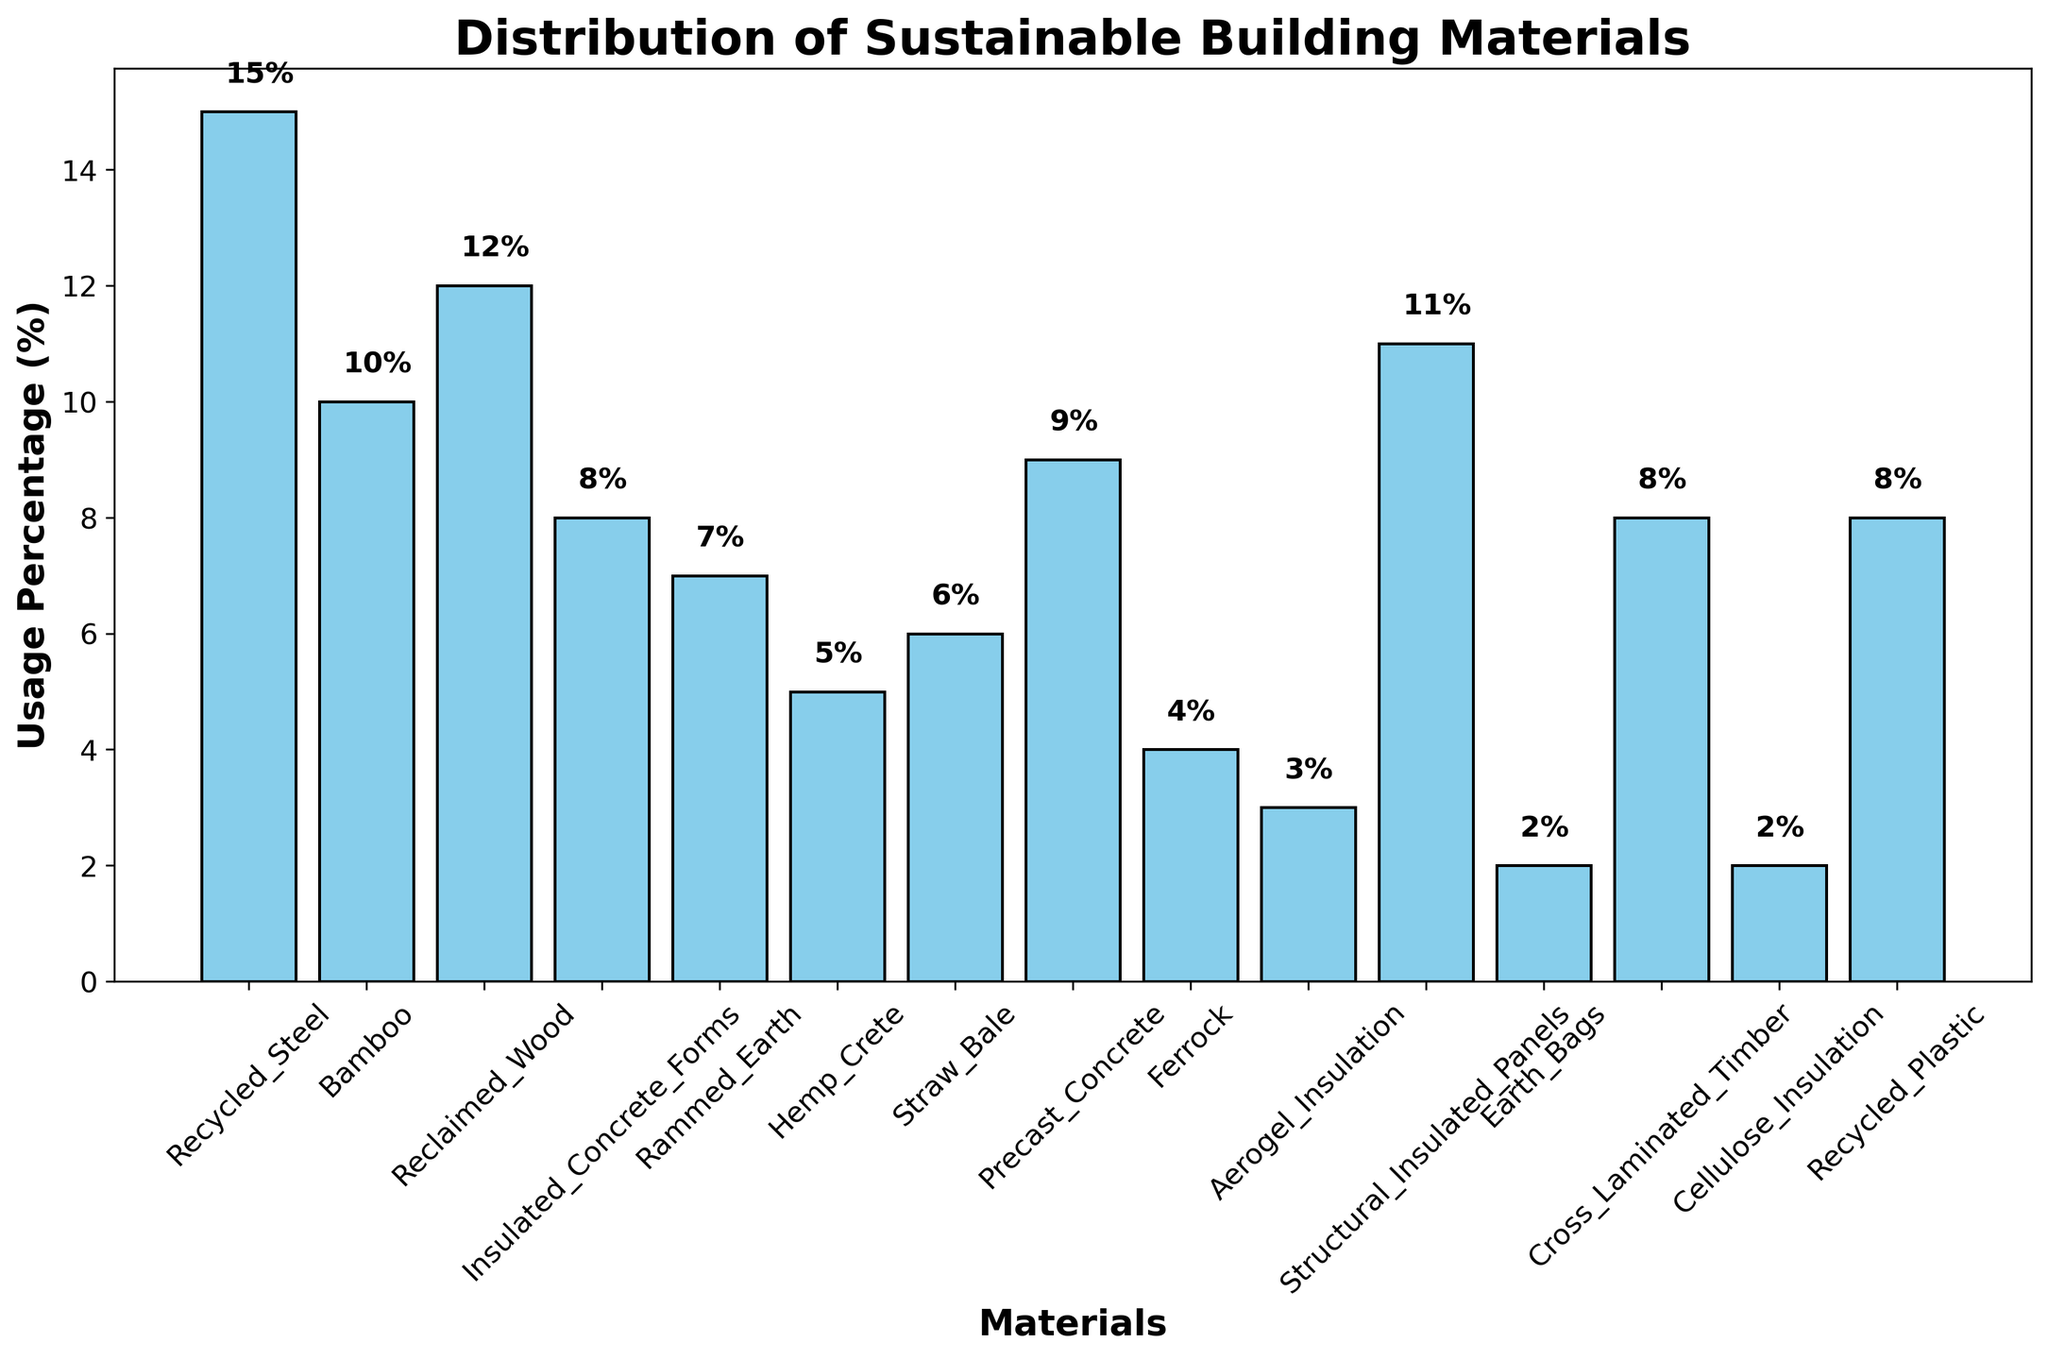Which material has the highest usage percentage? The bar representing Recycled Steel is the tallest among all the materials indicating it has the highest usage percentage.
Answer: Recycled Steel Which two materials have the lowest usage percentage, and what are their values? The bars for Earth Bags and Cellulose Insulation are the shortest among all the materials indicating they have the lowest usage percentages of 2%.
Answer: Earth Bags and Cellulose Insulation both at 2% Compare the usage of Bamboo and Reclaimed Wood. Which one is used more? The bar for Reclaimed Wood is higher than the bar for Bamboo. This indicates that Reclaimed Wood is used more than Bamboo. The usage percentages are 12% for Reclaimed Wood and 10% for Bamboo.
Answer: Reclaimed Wood What is the combined usage percentage of Insulated Concrete Forms, Cross Laminated Timber, and Recycled Plastic? The individual usage percentages for Insulated Concrete Forms, Cross Laminated Timber, and Recycled Plastic are 8% each. So, their combined usage is 8% + 8% + 8% = 24%.
Answer: 24% How does the usage percentage of Straw Bale compare to that of Hemp Crete? The bar for Straw Bale is taller than the bar for Hemp Crete. This indicates that Straw Bale has a higher usage percentage than Hemp Crete. The usage percentages are 6% for Straw Bale and 5% for Hemp Crete.
Answer: Straw Bale What is the average usage percentage of the materials listed? To find the average, sum up all the usage percentages and divide by the number of materials. The sum is 15 + 10 + 12 + 8 + 7 + 5 + 6 + 9 + 4 + 3 + 11 + 2 + 8 + 2 + 8 = 100. There are 15 materials, so the average usage percentage is 100 / 15 = 6.67%.
Answer: 6.67% Which material has a usage percentage closest to the average usage percentage? The average usage percentage is 6.67%. The material whose usage is closest to 6.67% is Straw Bale with a usage of 6%.
Answer: Straw Bale What is the difference in usage percentage between Ferrock and Aerogel Insulation? The usage percentage for Ferrock is 4%, and for Aerogel Insulation, it is 3%. The difference is 4% - 3% = 1%.
Answer: 1% If Cross Laminated Timber's usage increased by 50%, what would its new usage percentage be? Cross Laminated Timber’s current usage is 8%. Increasing it by 50% means 8% * 0.5 = 4%. The new usage percentage would be 8% + 4% = 12%.
Answer: 12% Which materials have a usage percentage greater than 10%? The data shows only materials with bars taller than 10% are Recycled Steel with 15%, Reclaimed Wood with 12%, and Structural Insulated Panels with 11%.
Answer: Recycled Steel, Reclaimed Wood, and Structural Insulated Panels 